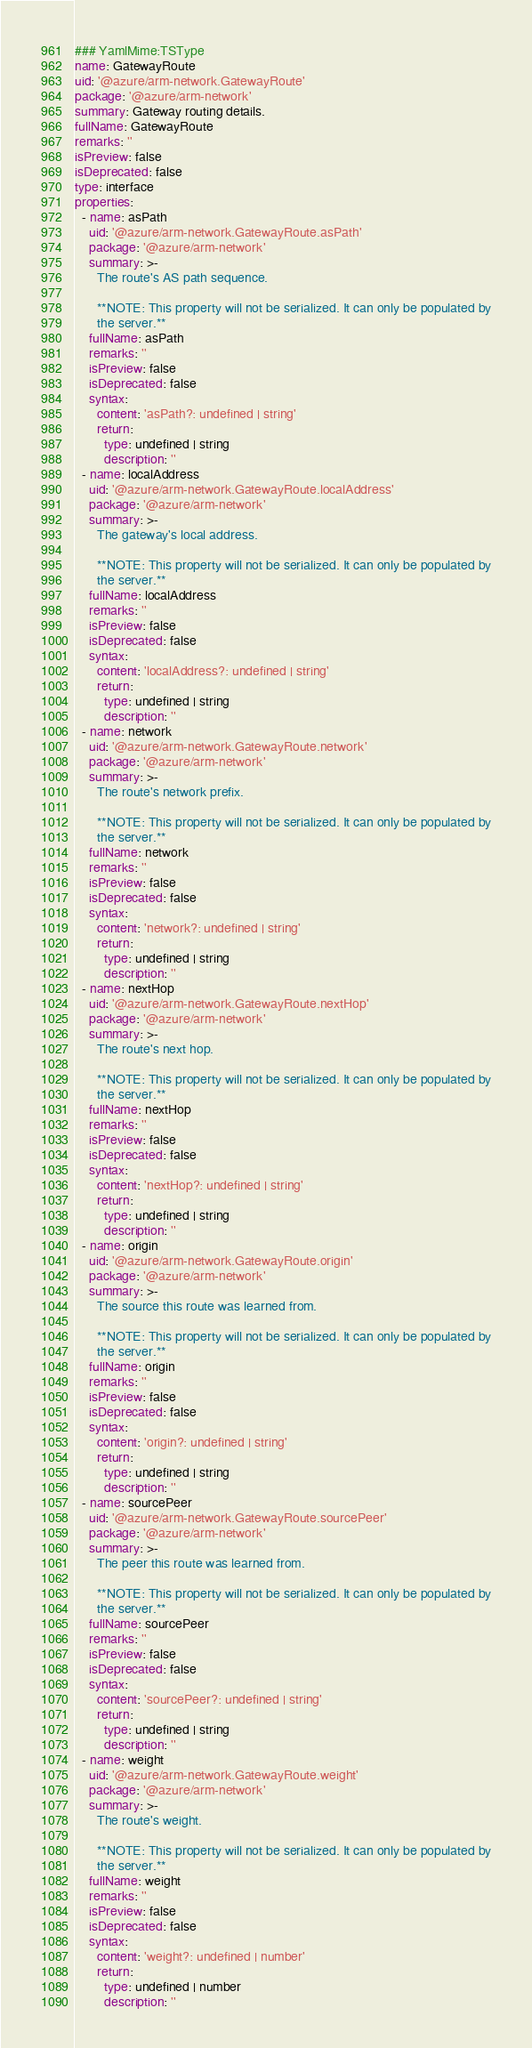<code> <loc_0><loc_0><loc_500><loc_500><_YAML_>### YamlMime:TSType
name: GatewayRoute
uid: '@azure/arm-network.GatewayRoute'
package: '@azure/arm-network'
summary: Gateway routing details.
fullName: GatewayRoute
remarks: ''
isPreview: false
isDeprecated: false
type: interface
properties:
  - name: asPath
    uid: '@azure/arm-network.GatewayRoute.asPath'
    package: '@azure/arm-network'
    summary: >-
      The route's AS path sequence.

      **NOTE: This property will not be serialized. It can only be populated by
      the server.**
    fullName: asPath
    remarks: ''
    isPreview: false
    isDeprecated: false
    syntax:
      content: 'asPath?: undefined | string'
      return:
        type: undefined | string
        description: ''
  - name: localAddress
    uid: '@azure/arm-network.GatewayRoute.localAddress'
    package: '@azure/arm-network'
    summary: >-
      The gateway's local address.

      **NOTE: This property will not be serialized. It can only be populated by
      the server.**
    fullName: localAddress
    remarks: ''
    isPreview: false
    isDeprecated: false
    syntax:
      content: 'localAddress?: undefined | string'
      return:
        type: undefined | string
        description: ''
  - name: network
    uid: '@azure/arm-network.GatewayRoute.network'
    package: '@azure/arm-network'
    summary: >-
      The route's network prefix.

      **NOTE: This property will not be serialized. It can only be populated by
      the server.**
    fullName: network
    remarks: ''
    isPreview: false
    isDeprecated: false
    syntax:
      content: 'network?: undefined | string'
      return:
        type: undefined | string
        description: ''
  - name: nextHop
    uid: '@azure/arm-network.GatewayRoute.nextHop'
    package: '@azure/arm-network'
    summary: >-
      The route's next hop.

      **NOTE: This property will not be serialized. It can only be populated by
      the server.**
    fullName: nextHop
    remarks: ''
    isPreview: false
    isDeprecated: false
    syntax:
      content: 'nextHop?: undefined | string'
      return:
        type: undefined | string
        description: ''
  - name: origin
    uid: '@azure/arm-network.GatewayRoute.origin'
    package: '@azure/arm-network'
    summary: >-
      The source this route was learned from.

      **NOTE: This property will not be serialized. It can only be populated by
      the server.**
    fullName: origin
    remarks: ''
    isPreview: false
    isDeprecated: false
    syntax:
      content: 'origin?: undefined | string'
      return:
        type: undefined | string
        description: ''
  - name: sourcePeer
    uid: '@azure/arm-network.GatewayRoute.sourcePeer'
    package: '@azure/arm-network'
    summary: >-
      The peer this route was learned from.

      **NOTE: This property will not be serialized. It can only be populated by
      the server.**
    fullName: sourcePeer
    remarks: ''
    isPreview: false
    isDeprecated: false
    syntax:
      content: 'sourcePeer?: undefined | string'
      return:
        type: undefined | string
        description: ''
  - name: weight
    uid: '@azure/arm-network.GatewayRoute.weight'
    package: '@azure/arm-network'
    summary: >-
      The route's weight.

      **NOTE: This property will not be serialized. It can only be populated by
      the server.**
    fullName: weight
    remarks: ''
    isPreview: false
    isDeprecated: false
    syntax:
      content: 'weight?: undefined | number'
      return:
        type: undefined | number
        description: ''
</code> 